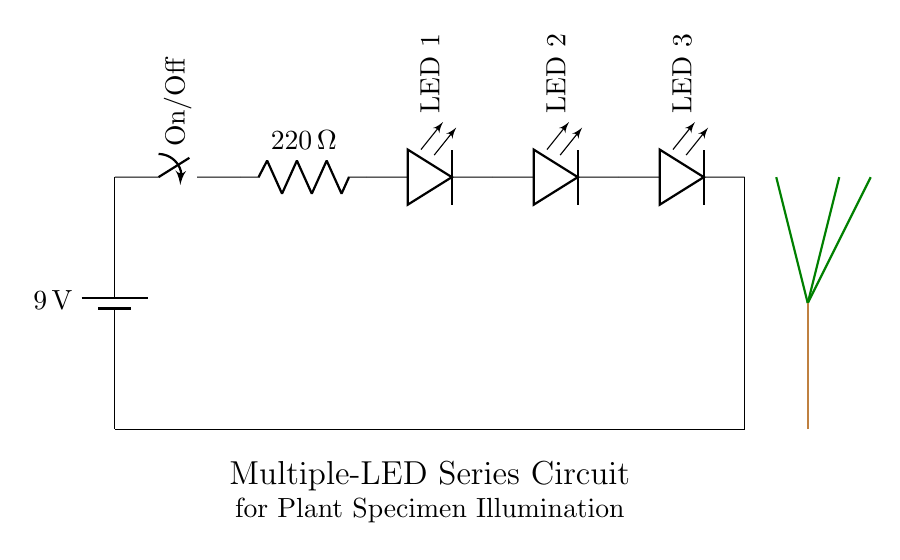What is the total voltage of the circuit? The circuit has a 9V battery as its power source, which provides the total voltage to the circuit.
Answer: 9 volts What is the resistance value in the circuit? There is one resistor in the circuit with a value of 220 ohms, as indicated in the diagram.
Answer: 220 ohms How many LED components are there? The diagram clearly shows three LED components connected in series with the battery and resistor.
Answer: Three What will happen if one LED fails? In a series circuit, if one component fails (like an LED), it will break the circuit and all LEDs will turn off, as current can no longer flow.
Answer: All LEDs turn off What is the purpose of the resistor in this circuit? The resistor is used to limit the current flowing through the LEDs to prevent them from burning out, as LEDs have a maximum current rating.
Answer: Current limiter How are the LEDs arranged in the circuit? The LEDs are arranged in series, meaning they are connected end-to-end, sharing the same current throughout the circuit.
Answer: In series What is the purpose of the switch in the circuit? The switch is included to provide a way to turn the circuit on or off, controlling whether the LEDs are illuminated or not.
Answer: On/Off control 